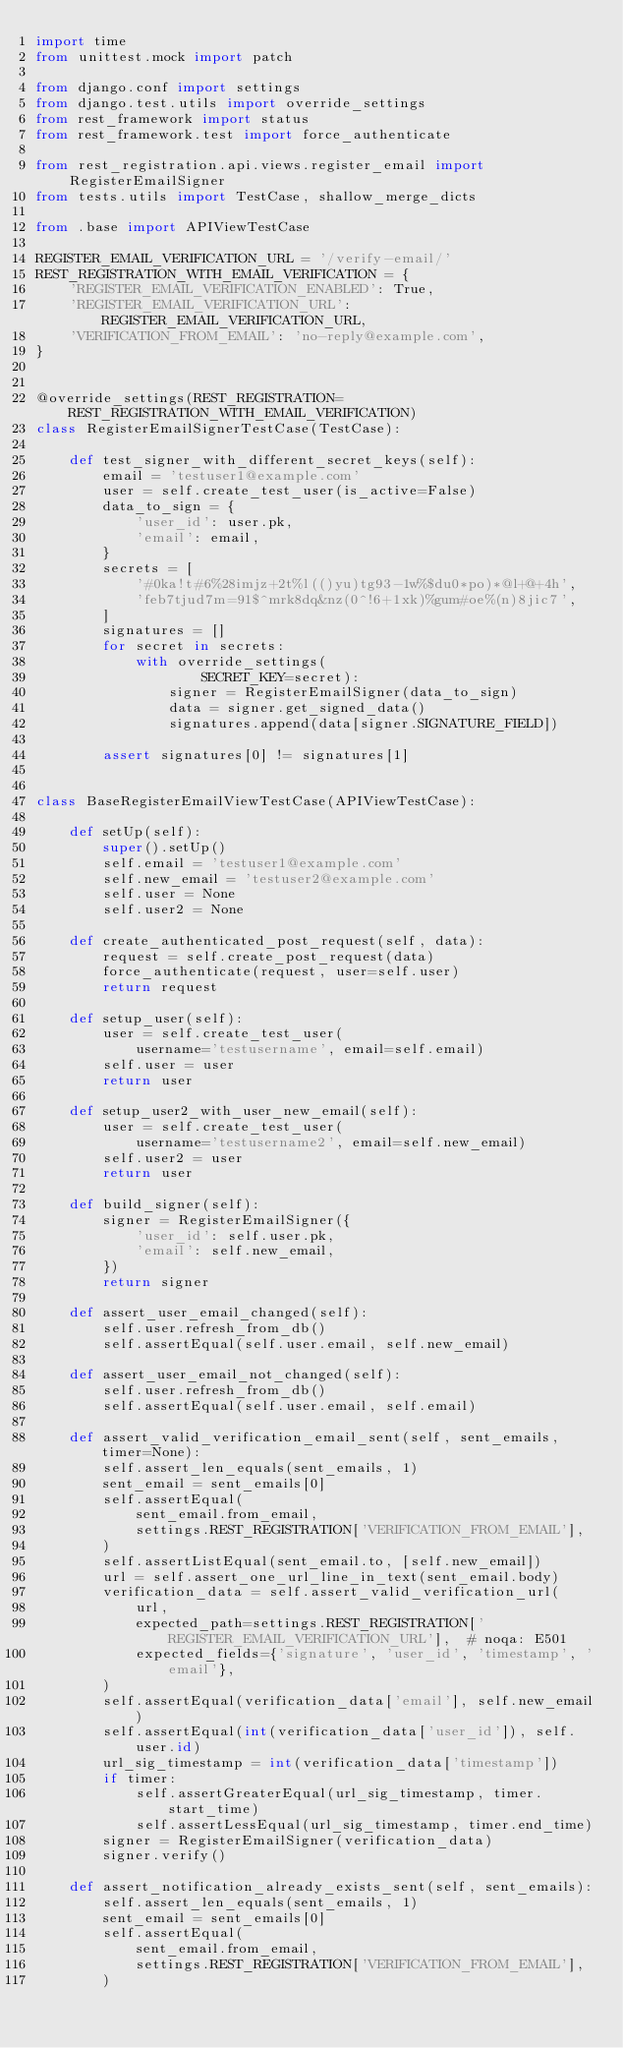Convert code to text. <code><loc_0><loc_0><loc_500><loc_500><_Python_>import time
from unittest.mock import patch

from django.conf import settings
from django.test.utils import override_settings
from rest_framework import status
from rest_framework.test import force_authenticate

from rest_registration.api.views.register_email import RegisterEmailSigner
from tests.utils import TestCase, shallow_merge_dicts

from .base import APIViewTestCase

REGISTER_EMAIL_VERIFICATION_URL = '/verify-email/'
REST_REGISTRATION_WITH_EMAIL_VERIFICATION = {
    'REGISTER_EMAIL_VERIFICATION_ENABLED': True,
    'REGISTER_EMAIL_VERIFICATION_URL': REGISTER_EMAIL_VERIFICATION_URL,
    'VERIFICATION_FROM_EMAIL': 'no-reply@example.com',
}


@override_settings(REST_REGISTRATION=REST_REGISTRATION_WITH_EMAIL_VERIFICATION)
class RegisterEmailSignerTestCase(TestCase):

    def test_signer_with_different_secret_keys(self):
        email = 'testuser1@example.com'
        user = self.create_test_user(is_active=False)
        data_to_sign = {
            'user_id': user.pk,
            'email': email,
        }
        secrets = [
            '#0ka!t#6%28imjz+2t%l(()yu)tg93-1w%$du0*po)*@l+@+4h',
            'feb7tjud7m=91$^mrk8dq&nz(0^!6+1xk)%gum#oe%(n)8jic7',
        ]
        signatures = []
        for secret in secrets:
            with override_settings(
                    SECRET_KEY=secret):
                signer = RegisterEmailSigner(data_to_sign)
                data = signer.get_signed_data()
                signatures.append(data[signer.SIGNATURE_FIELD])

        assert signatures[0] != signatures[1]


class BaseRegisterEmailViewTestCase(APIViewTestCase):

    def setUp(self):
        super().setUp()
        self.email = 'testuser1@example.com'
        self.new_email = 'testuser2@example.com'
        self.user = None
        self.user2 = None

    def create_authenticated_post_request(self, data):
        request = self.create_post_request(data)
        force_authenticate(request, user=self.user)
        return request

    def setup_user(self):
        user = self.create_test_user(
            username='testusername', email=self.email)
        self.user = user
        return user

    def setup_user2_with_user_new_email(self):
        user = self.create_test_user(
            username='testusername2', email=self.new_email)
        self.user2 = user
        return user

    def build_signer(self):
        signer = RegisterEmailSigner({
            'user_id': self.user.pk,
            'email': self.new_email,
        })
        return signer

    def assert_user_email_changed(self):
        self.user.refresh_from_db()
        self.assertEqual(self.user.email, self.new_email)

    def assert_user_email_not_changed(self):
        self.user.refresh_from_db()
        self.assertEqual(self.user.email, self.email)

    def assert_valid_verification_email_sent(self, sent_emails, timer=None):
        self.assert_len_equals(sent_emails, 1)
        sent_email = sent_emails[0]
        self.assertEqual(
            sent_email.from_email,
            settings.REST_REGISTRATION['VERIFICATION_FROM_EMAIL'],
        )
        self.assertListEqual(sent_email.to, [self.new_email])
        url = self.assert_one_url_line_in_text(sent_email.body)
        verification_data = self.assert_valid_verification_url(
            url,
            expected_path=settings.REST_REGISTRATION['REGISTER_EMAIL_VERIFICATION_URL'],  # noqa: E501
            expected_fields={'signature', 'user_id', 'timestamp', 'email'},
        )
        self.assertEqual(verification_data['email'], self.new_email)
        self.assertEqual(int(verification_data['user_id']), self.user.id)
        url_sig_timestamp = int(verification_data['timestamp'])
        if timer:
            self.assertGreaterEqual(url_sig_timestamp, timer.start_time)
            self.assertLessEqual(url_sig_timestamp, timer.end_time)
        signer = RegisterEmailSigner(verification_data)
        signer.verify()

    def assert_notification_already_exists_sent(self, sent_emails):
        self.assert_len_equals(sent_emails, 1)
        sent_email = sent_emails[0]
        self.assertEqual(
            sent_email.from_email,
            settings.REST_REGISTRATION['VERIFICATION_FROM_EMAIL'],
        )</code> 